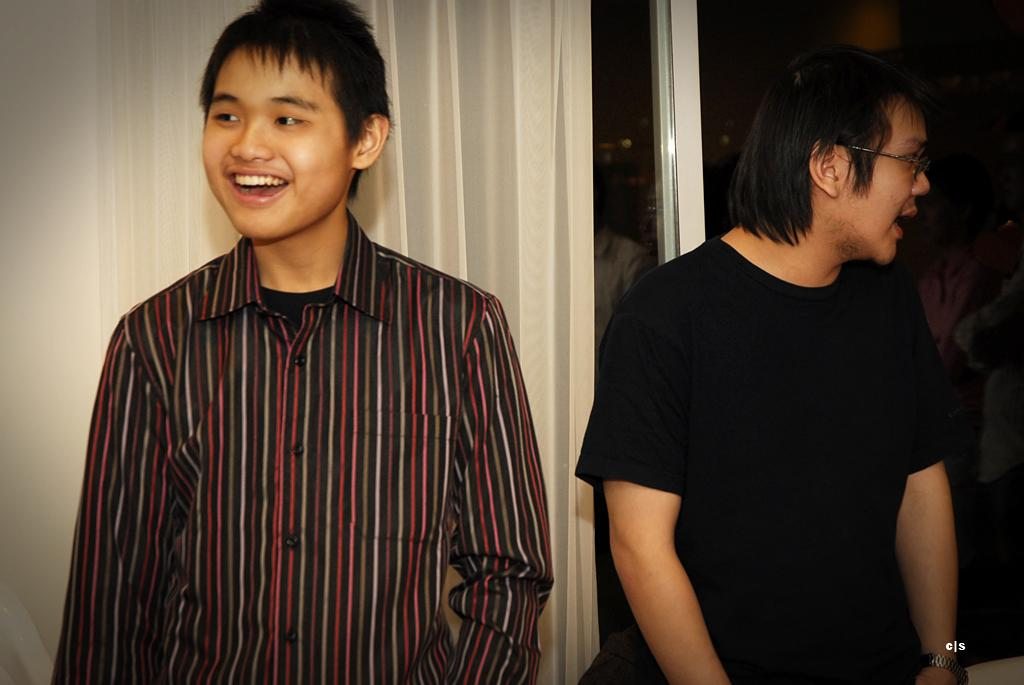How many people are in the image? There are two men in the image. What is the facial expression of one of the men? One of the men is smiling. What accessory does the smiling man have? The smiling man has spectacles. What can be seen in the background of the image? There is a curtain and glass in the background of the image. What type of mitten is the man wearing in the image? There is no mitten visible in the image; the smiling man is wearing spectacles. What kind of vessel is being used by the men in the image? There is no vessel present in the image; the men are not shown using any objects besides their spectacles. 